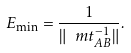Convert formula to latex. <formula><loc_0><loc_0><loc_500><loc_500>E _ { \min } = \frac { 1 } { \| \ m t ^ { - 1 } _ { A B } \| } .</formula> 